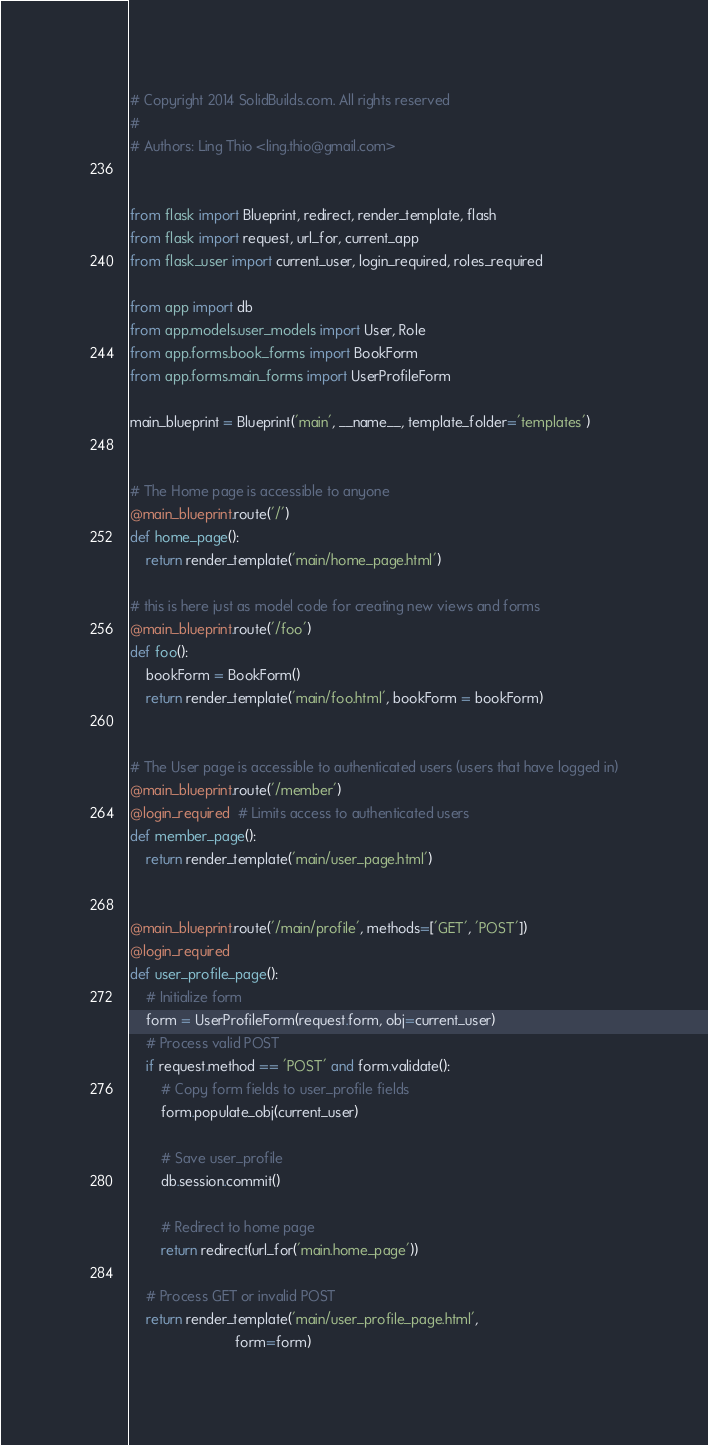Convert code to text. <code><loc_0><loc_0><loc_500><loc_500><_Python_># Copyright 2014 SolidBuilds.com. All rights reserved
#
# Authors: Ling Thio <ling.thio@gmail.com>


from flask import Blueprint, redirect, render_template, flash
from flask import request, url_for, current_app
from flask_user import current_user, login_required, roles_required

from app import db
from app.models.user_models import User, Role
from app.forms.book_forms import BookForm
from app.forms.main_forms import UserProfileForm

main_blueprint = Blueprint('main', __name__, template_folder='templates')


# The Home page is accessible to anyone
@main_blueprint.route('/')
def home_page():
    return render_template('main/home_page.html')

# this is here just as model code for creating new views and forms
@main_blueprint.route('/foo')
def foo():
    bookForm = BookForm()
    return render_template('main/foo.html', bookForm = bookForm)


# The User page is accessible to authenticated users (users that have logged in)
@main_blueprint.route('/member')
@login_required  # Limits access to authenticated users
def member_page():
    return render_template('main/user_page.html')


@main_blueprint.route('/main/profile', methods=['GET', 'POST'])
@login_required
def user_profile_page():
    # Initialize form
    form = UserProfileForm(request.form, obj=current_user)
    # Process valid POST
    if request.method == 'POST' and form.validate():
        # Copy form fields to user_profile fields
        form.populate_obj(current_user)

        # Save user_profile
        db.session.commit()

        # Redirect to home page
        return redirect(url_for('main.home_page'))

    # Process GET or invalid POST
    return render_template('main/user_profile_page.html',
                           form=form)



</code> 